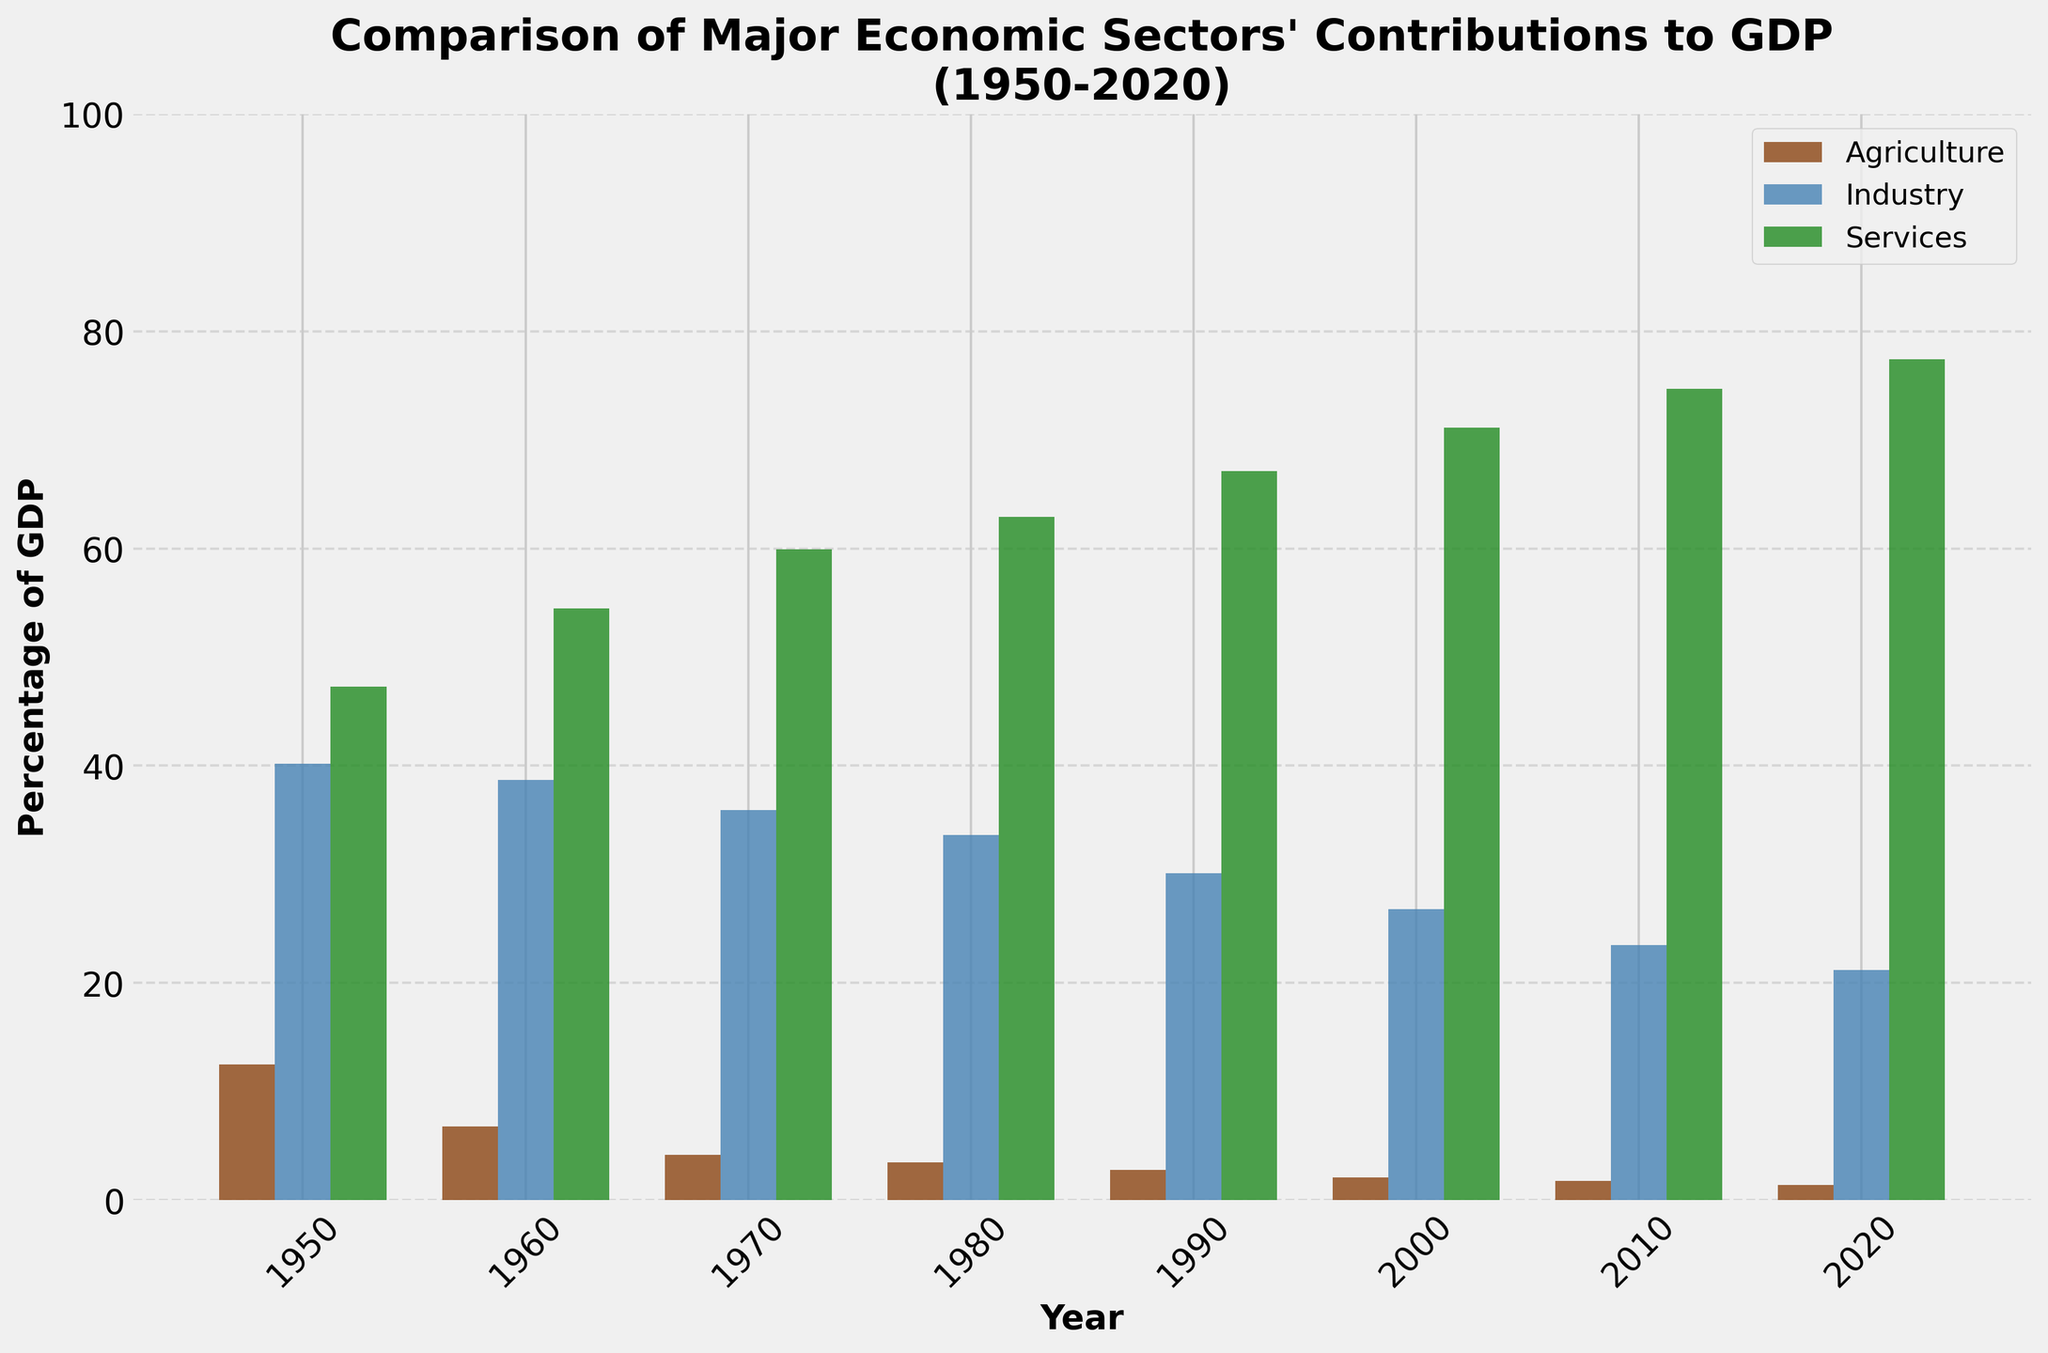What major economic sector had the highest percentage contribution to GDP in 1950? The figure shows different sectors for each year, and by looking at the bars for 1950, the Services sector has the highest percentage contribution among Agriculture, Industry, and Services.
Answer: Services By how much did the contribution of the Agriculture sector decrease from 1950 to 2020? In 1950, the Agriculture sector contributed 12.5% and in 2020 it contributed 1.4%. The decrease is calculated as 12.5% - 1.4% = 11.1%.
Answer: 11.1% Between which consecutive decades did the Services sector see the biggest increase in its contribution to GDP? Looking at the change in the height of the bars for the Services sector over each decade, the biggest jump is between 1950 (47.3%) and 1960 (54.5%), which is 54.5% - 47.3% = 7.2%.
Answer: 1950 and 1960 What is the sum of the contributions to GDP of all sectors in 1990? The contributions to GDP in 1990 for Agriculture, Industry, and Services are 2.8%, 30.1%, and 67.1%, respectively. Summing these, 2.8% + 30.1% + 67.1% = 100%.
Answer: 100% Which sector consistently had the lowest contribution to GDP throughout the years 1950-2020? By comparing the bar heights for all sectors over the years, the Agriculture sector consistently has the shortest bars, indicating the lowest percentage of GDP contribution.
Answer: Agriculture From 1980 to 2000, did the Industry sector's percentage contribution to GDP increase, decrease, or stay the same? The Industry sector's contribution in 1980 was 33.6% and in 2000 it was 26.8%. This shows a decrease in contribution over these years.
Answer: Decrease How does the total contribution of the Industry sector over the entire period (1950-2020) compare with the contribution of the Services sector in the year 2020 alone? Sum the contributions of the Industry sector (40.2% + 38.7% + 35.9% + 33.6% + 30.1% + 26.8% + 23.5% + 21.2%) = 250%, while the Services sector contribution in 2020 is 77.4%. The total contribution of the Industry sector over all years is higher.
Answer: Higher Which sector's bars show the most consistent (least variable) height over the decades? Observing the bars, the Services sector shows the most consistent upward trend, indicating less variability in the direction of the trend, whereas Agriculture and Industry show considerable declines.
Answer: Services 